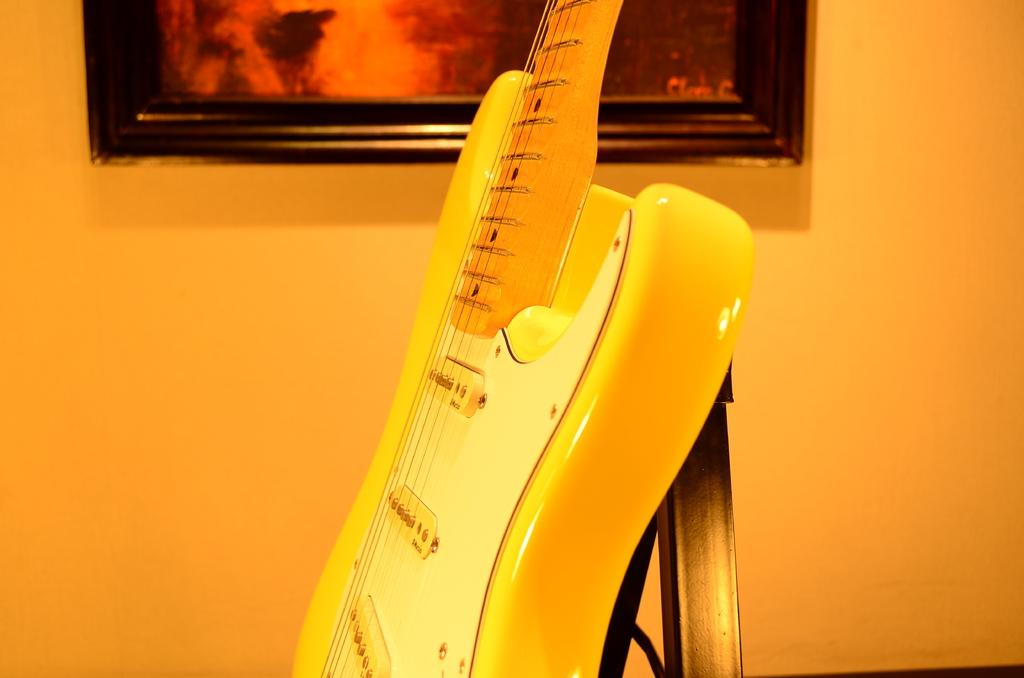What object in the image is used for creating music? There is a musical instrument in the image. What can be seen on the wall in the background? There is a frame attached to the wall in the background. What color is the wall in the image? The wall is in orange color. What degree does the cart have in the image? There is no cart present in the image, so it is not possible to determine if it has a degree. 